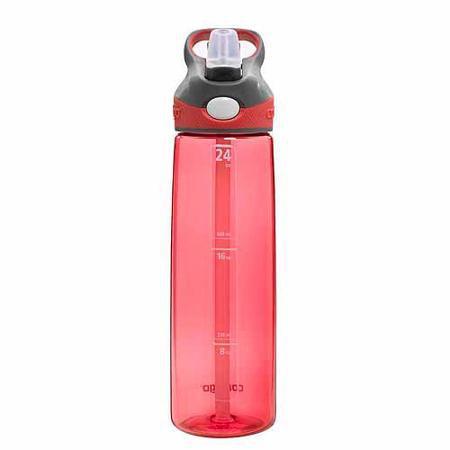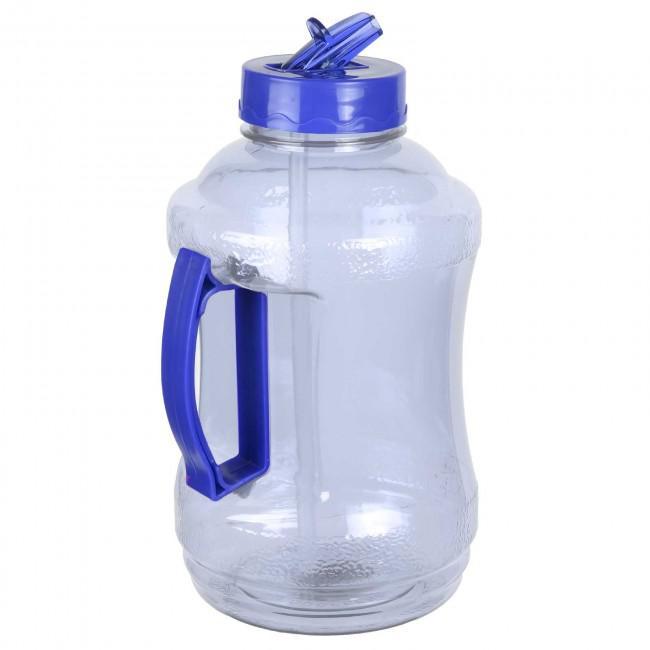The first image is the image on the left, the second image is the image on the right. For the images displayed, is the sentence "Each image shows a bottle shaped like a cylinder with straight sides, and the water bottle on the right is pink with a pattern of small black ovals and has a green cap with a loop on the right." factually correct? Answer yes or no. No. The first image is the image on the left, the second image is the image on the right. Assess this claim about the two images: "Two water bottles both have matching caps, but are different colors and one bottle is much bigger.". Correct or not? Answer yes or no. Yes. 